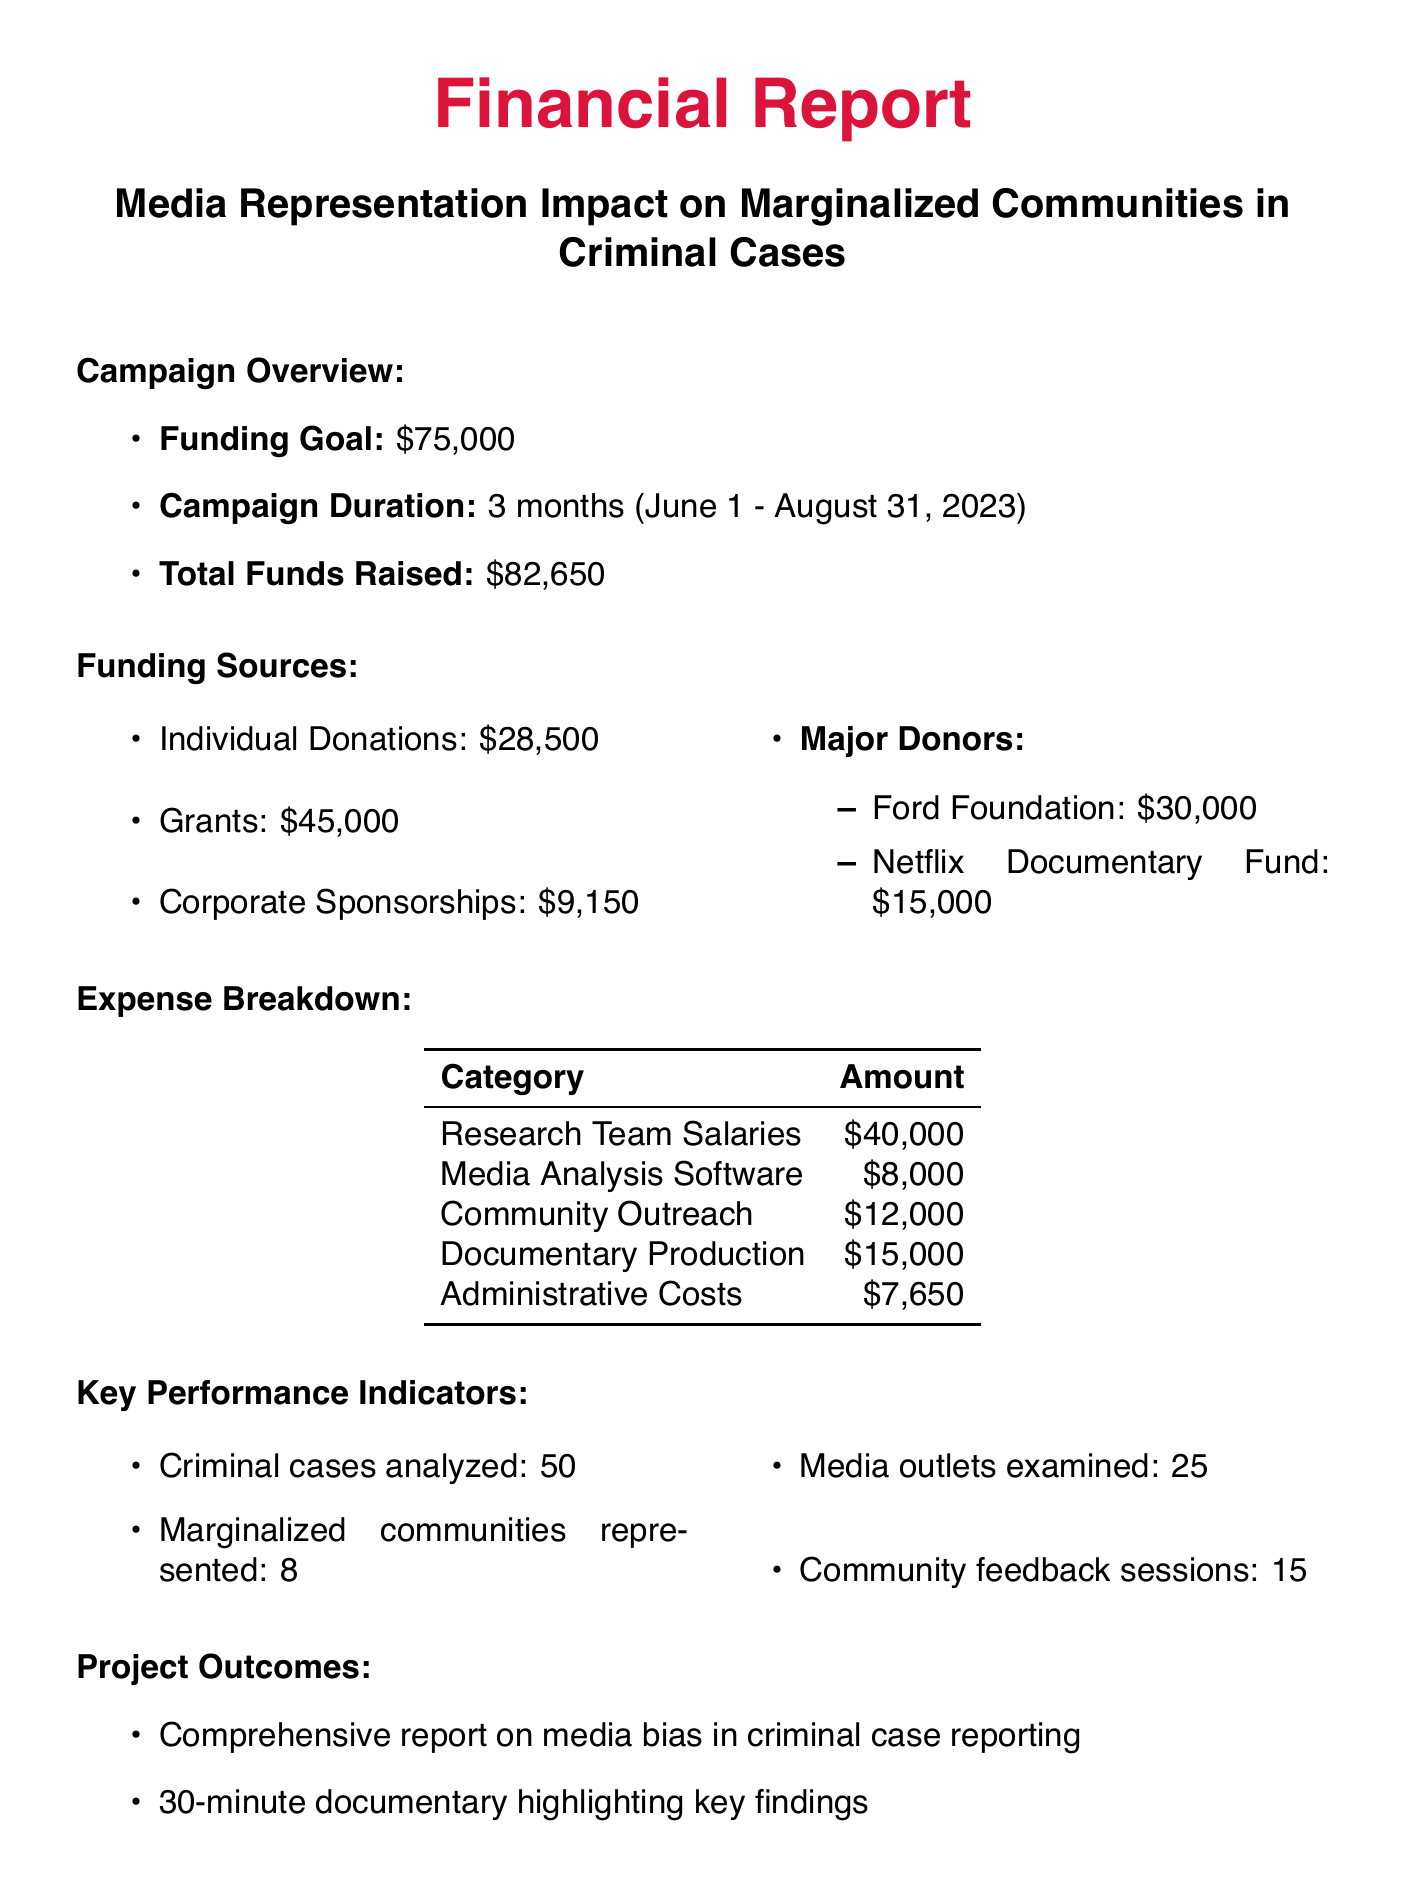what is the funding goal? The funding goal is specified explicitly in the document as the target amount for the campaign.
Answer: $75,000 how much was raised from individual donations? The amount raised from individual donations is clearly mentioned in the funding sources section.
Answer: $28,500 who is one of the major donors? The document lists major donors along with the amounts they've contributed, providing specific names.
Answer: Ford Foundation what percentage of the total funds raised came from grants? This requires calculating the ratio of grants to total funds raised based on the provided figures in the document.
Answer: 54.5% how many marginal communities were represented in the project? The document explicitly states the number of marginalized communities represented in the key performance indicators section.
Answer: 8 what are the total administrative costs? The administrative costs amount is detailed in the expense breakdown section of the document.
Answer: $7,650 what is the total amount of future funding needs? This information is found towards the end of the document, specifying the required funds for future initiatives.
Answer: $50,000 how many community feedback sessions were conducted? The key performance indicators section provides the number of feedback sessions that were held during the campaign.
Answer: 15 what kind of report was produced as a project outcome? The document outlines specific outcomes of the project, including types of reports produced.
Answer: Comprehensive report on media bias in criminal case reporting 